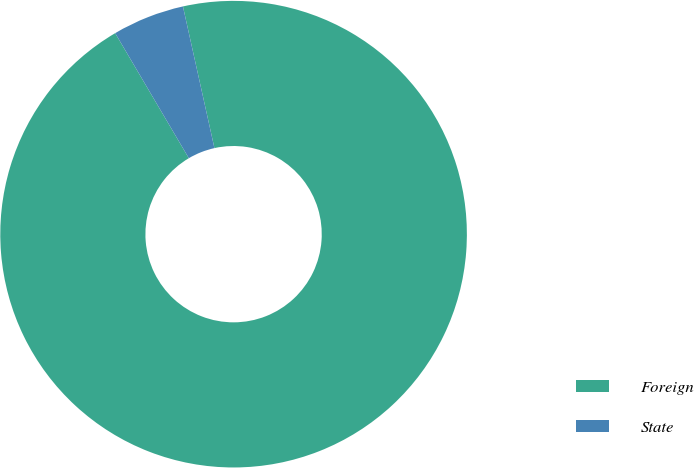Convert chart to OTSL. <chart><loc_0><loc_0><loc_500><loc_500><pie_chart><fcel>Foreign<fcel>State<nl><fcel>95.01%<fcel>4.99%<nl></chart> 